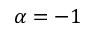<formula> <loc_0><loc_0><loc_500><loc_500>\alpha = - 1</formula> 